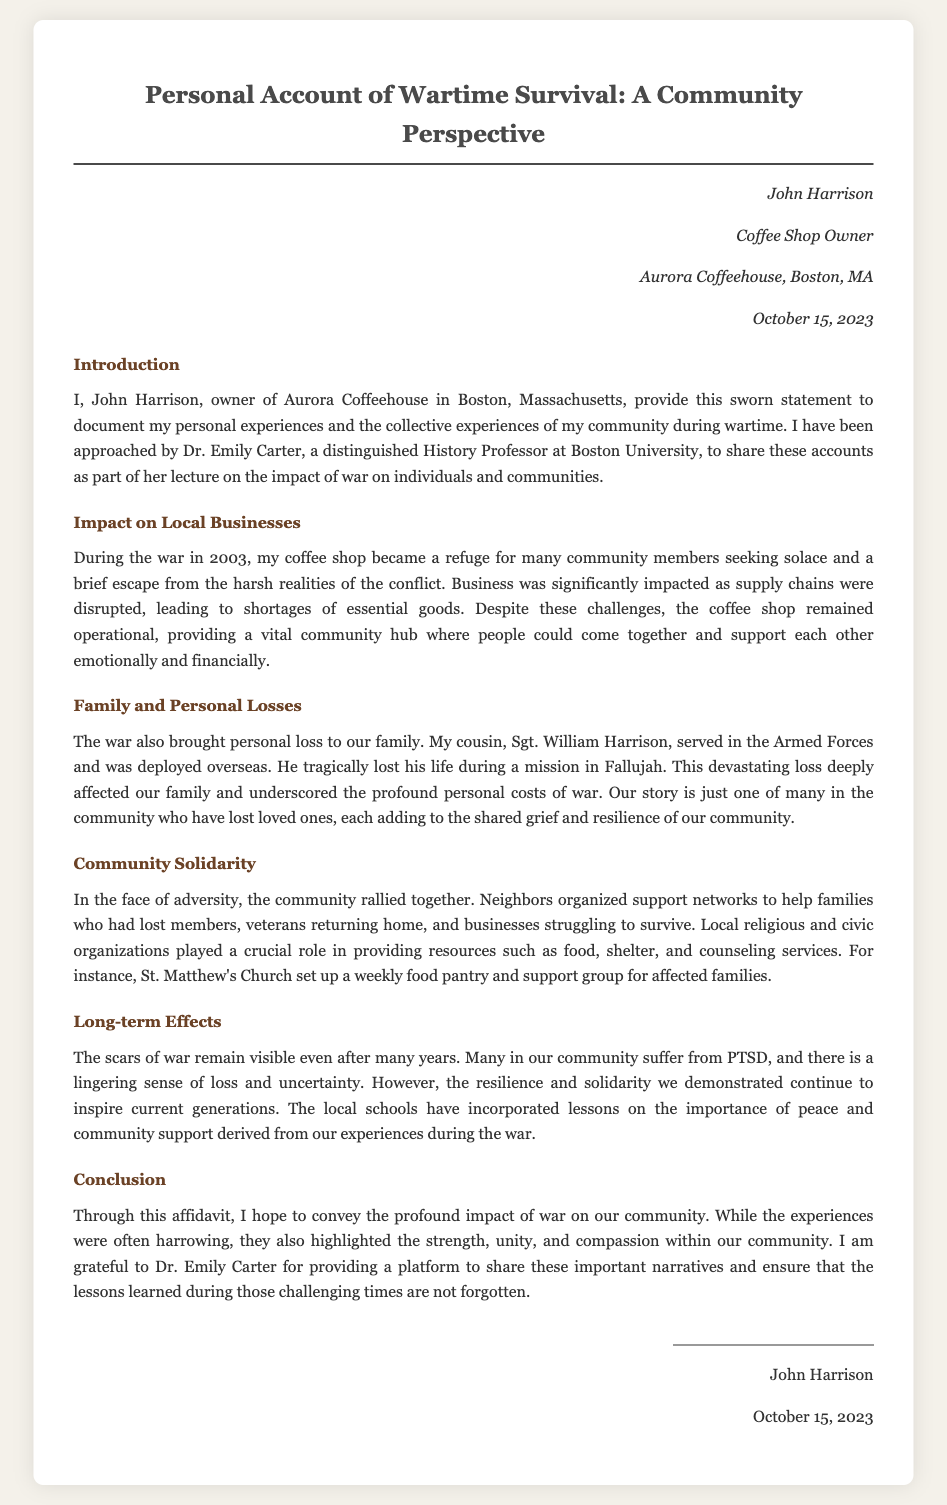What is the name of the coffee shop owner? The document mentions the owner's name as John Harrison.
Answer: John Harrison What is the name of the coffee shop? The document states the name of the coffee shop as Aurora Coffeehouse.
Answer: Aurora Coffeehouse In what year did the war mentioned in the document occur? The document refers to the war taking place in the year 2003.
Answer: 2003 Who did John Harrison provide his sworn statement to? The document indicates that he provided his statement to Dr. Emily Carter.
Answer: Dr. Emily Carter What is one personal loss mentioned in the document? The document mentions the loss of John Harrison's cousin, Sgt. William Harrison, during the war.
Answer: Sgt. William Harrison What role did St. Matthew's Church play during the war? The document states that St. Matthew's Church set up a weekly food pantry and support group for affected families.
Answer: Weekly food pantry and support group What are the long-term effects of war mentioned in the document? The document indicates that many in the community suffer from PTSD and a lingering sense of loss.
Answer: PTSD and a lingering sense of loss What does the document highlight about community response during the war? The document emphasizes that the community rallied together and organized support networks.
Answer: Organized support networks What is the primary purpose of this affidavit? The document states that the purpose of the affidavit is to convey the impact of war on the community.
Answer: Convey the impact of war on the community 